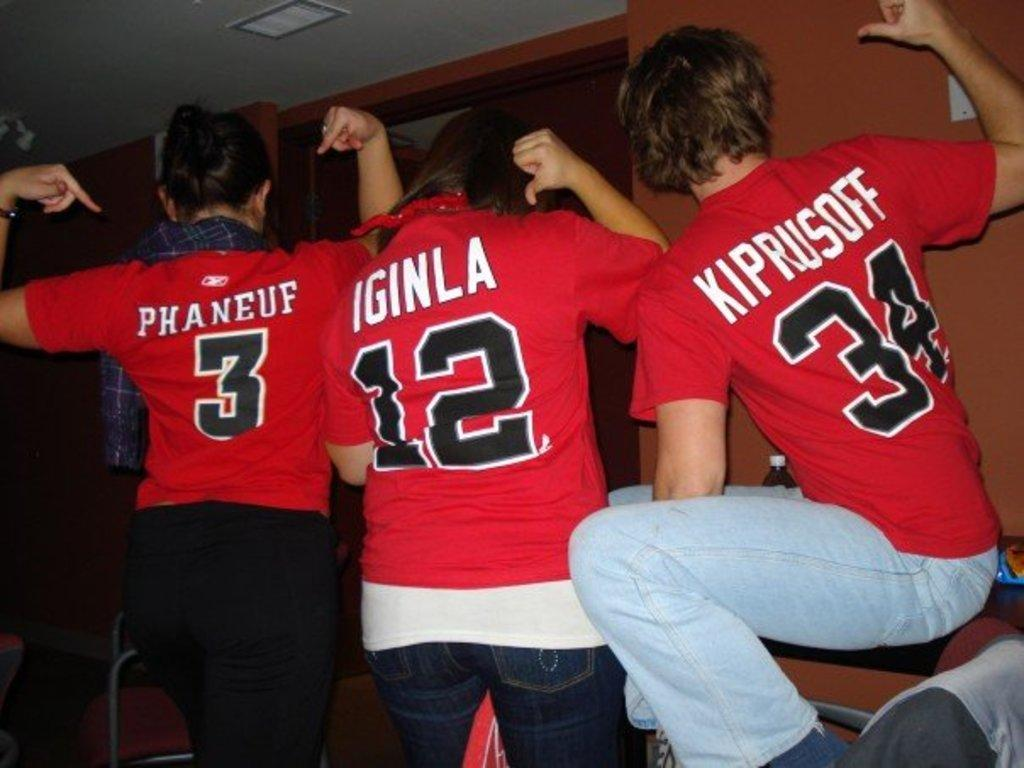<image>
Provide a brief description of the given image. A group of kids are wearing matching red shirts that say Phaneuf, Iginla, and Kiprusoff. 